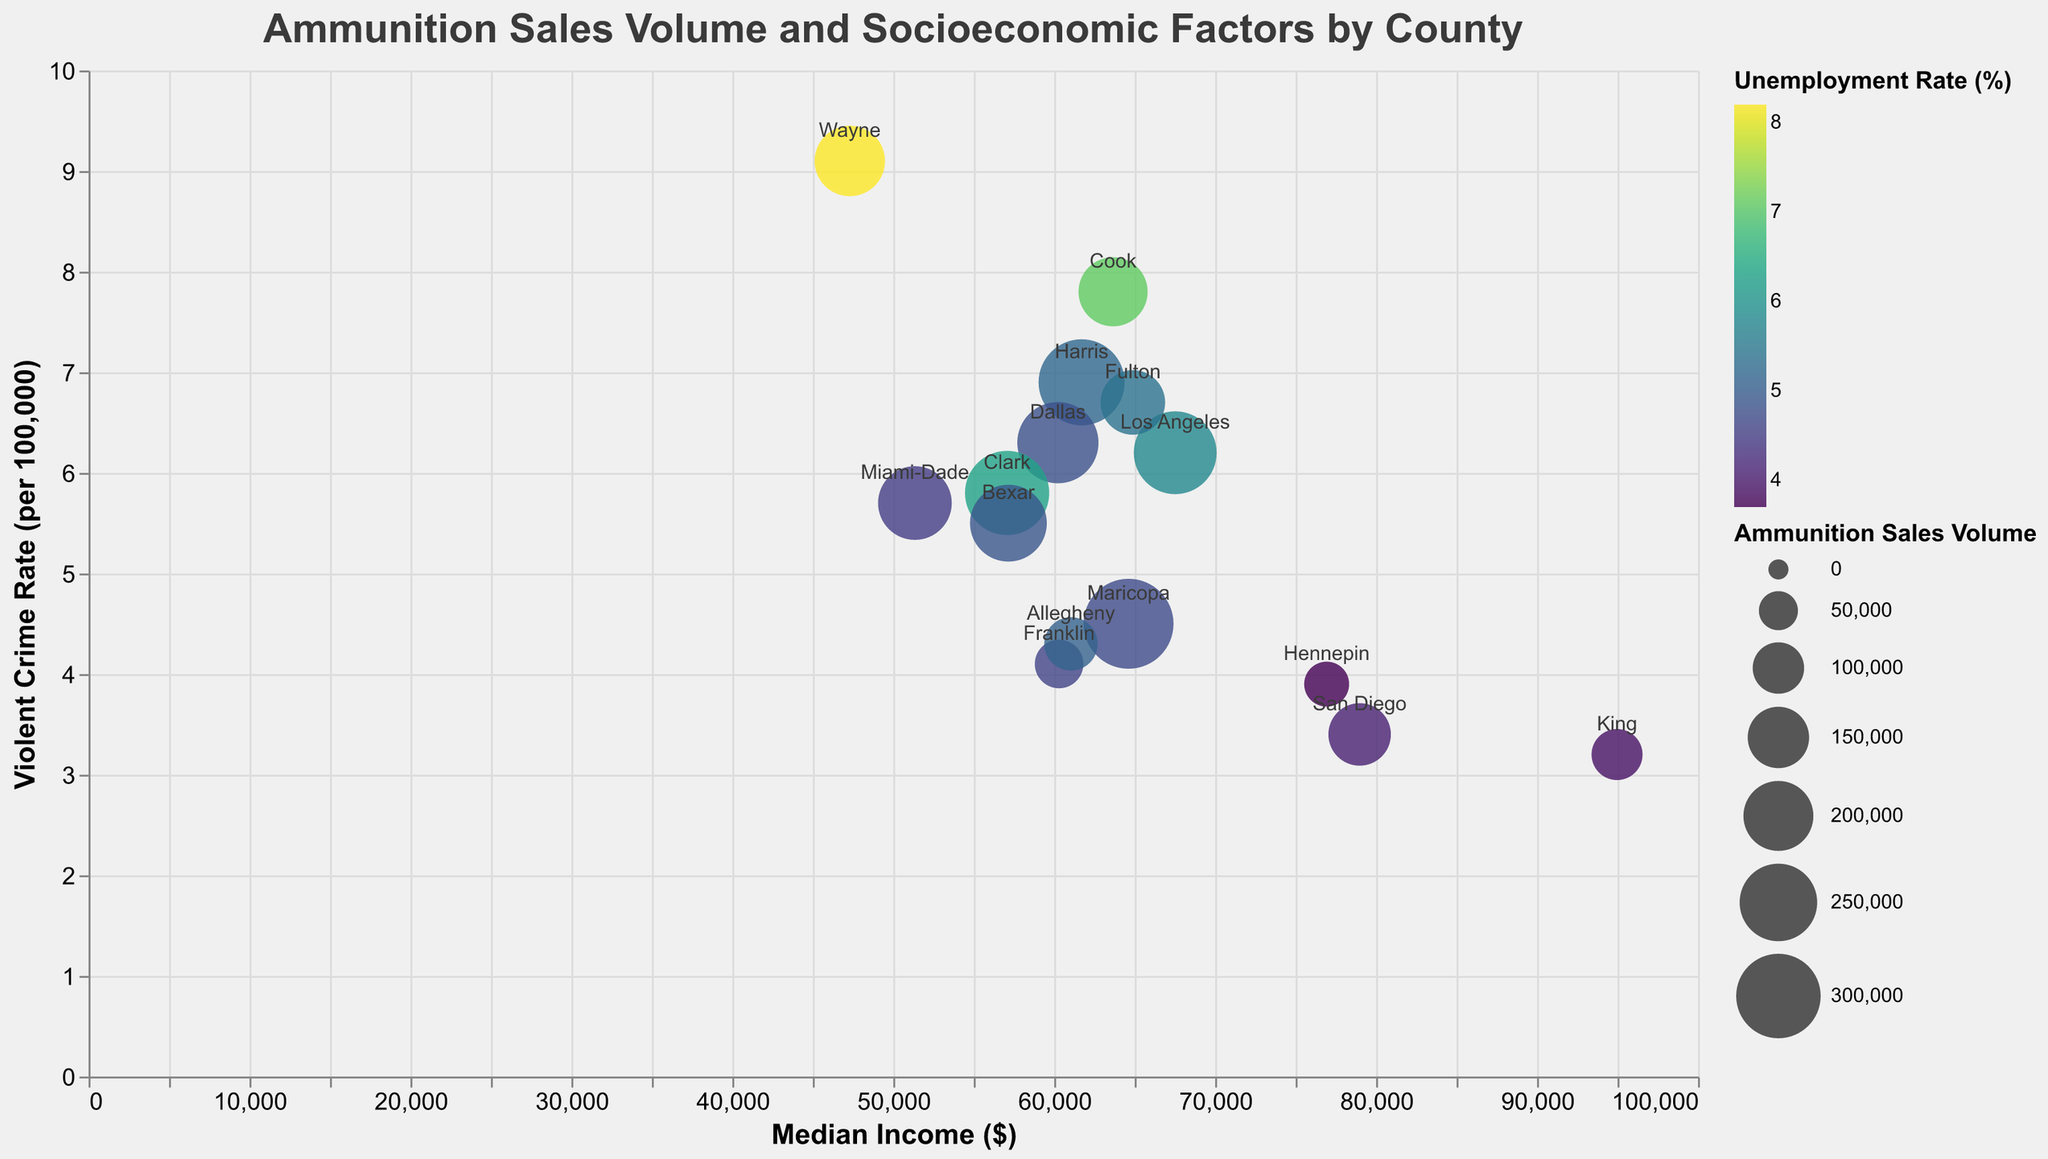How many data points are there on the plot? Count the number of circles shown on the plot. Each circle represents one county.
Answer: 15 What is the title of the plot? Look at the text at the top center of the figure; it typically contains the title.
Answer: Ammunition Sales Volume and Socioeconomic Factors by County Which county has the highest ammunition sales volume? Identify the largest circle on the plot, as circle size represents ammunition sales volume. From the tooltip, you can verify the value.
Answer: Maricopa Which county has the lowest violent crime rate and what is its unemployment rate? Find the county located furthest down on the y-axis. Use the tooltip to identify the county and its unemployment rate.
Answer: King, 3.9% How does Franklin County's ammunition sales volume compare to that of Hennepin County? Locate both counties on the plot and compare the sizes of their circles; larger circles indicate higher sales volumes. Verify with tooltips if needed.
Answer: Franklin's is higher Which states have counties represented in this plot? From the tooltip or circle labels, note the state names alongside county names.
Answer: California, Illinois, Texas, Arizona, Washington, Florida, Michigan, Nevada, Ohio, Minnesota, Georgia, Pennsylvania Which county has the most significant discrepancy between its ammunition sales volume and violent crime rate? Observe the plot; larger circles (high ammo sales) with lower positions on the y-axis (lower crime rates) or vice versa will show discrepancies. Use tooltips for precise values. Dallas, 276000 sales volume with 6.3 violent crime rate vs Clark, 298000 sales volume with 5.8 violent crime rate.
Answer: Clark 